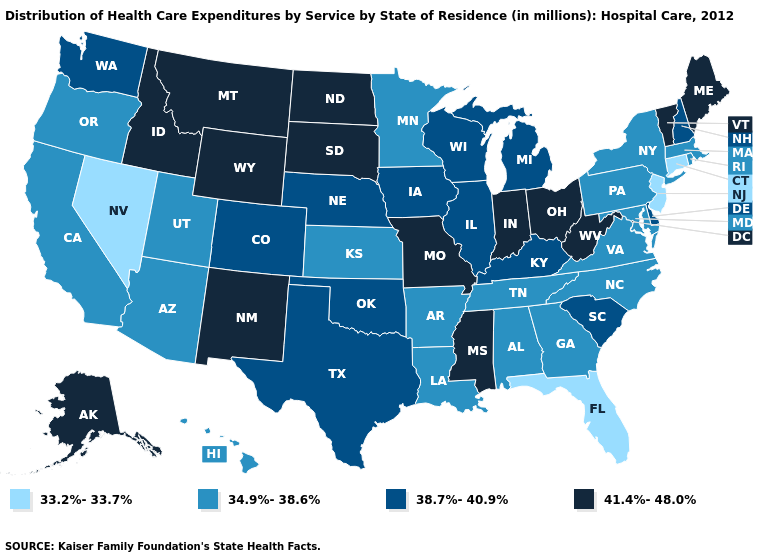What is the highest value in the South ?
Short answer required. 41.4%-48.0%. Name the states that have a value in the range 33.2%-33.7%?
Keep it brief. Connecticut, Florida, Nevada, New Jersey. Among the states that border Wyoming , which have the lowest value?
Keep it brief. Utah. Does the map have missing data?
Concise answer only. No. Name the states that have a value in the range 38.7%-40.9%?
Answer briefly. Colorado, Delaware, Illinois, Iowa, Kentucky, Michigan, Nebraska, New Hampshire, Oklahoma, South Carolina, Texas, Washington, Wisconsin. Name the states that have a value in the range 38.7%-40.9%?
Give a very brief answer. Colorado, Delaware, Illinois, Iowa, Kentucky, Michigan, Nebraska, New Hampshire, Oklahoma, South Carolina, Texas, Washington, Wisconsin. What is the value of Florida?
Quick response, please. 33.2%-33.7%. Does Idaho have the highest value in the USA?
Quick response, please. Yes. Among the states that border Indiana , which have the lowest value?
Be succinct. Illinois, Kentucky, Michigan. Is the legend a continuous bar?
Concise answer only. No. Name the states that have a value in the range 41.4%-48.0%?
Short answer required. Alaska, Idaho, Indiana, Maine, Mississippi, Missouri, Montana, New Mexico, North Dakota, Ohio, South Dakota, Vermont, West Virginia, Wyoming. What is the highest value in the USA?
Answer briefly. 41.4%-48.0%. What is the highest value in the South ?
Concise answer only. 41.4%-48.0%. What is the value of Montana?
Keep it brief. 41.4%-48.0%. What is the value of Utah?
Write a very short answer. 34.9%-38.6%. 